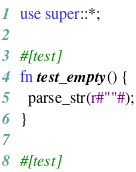Convert code to text. <code><loc_0><loc_0><loc_500><loc_500><_Rust_>use super::*;

#[test]
fn test_empty() {
  parse_str(r#""#);
}

#[test]</code> 